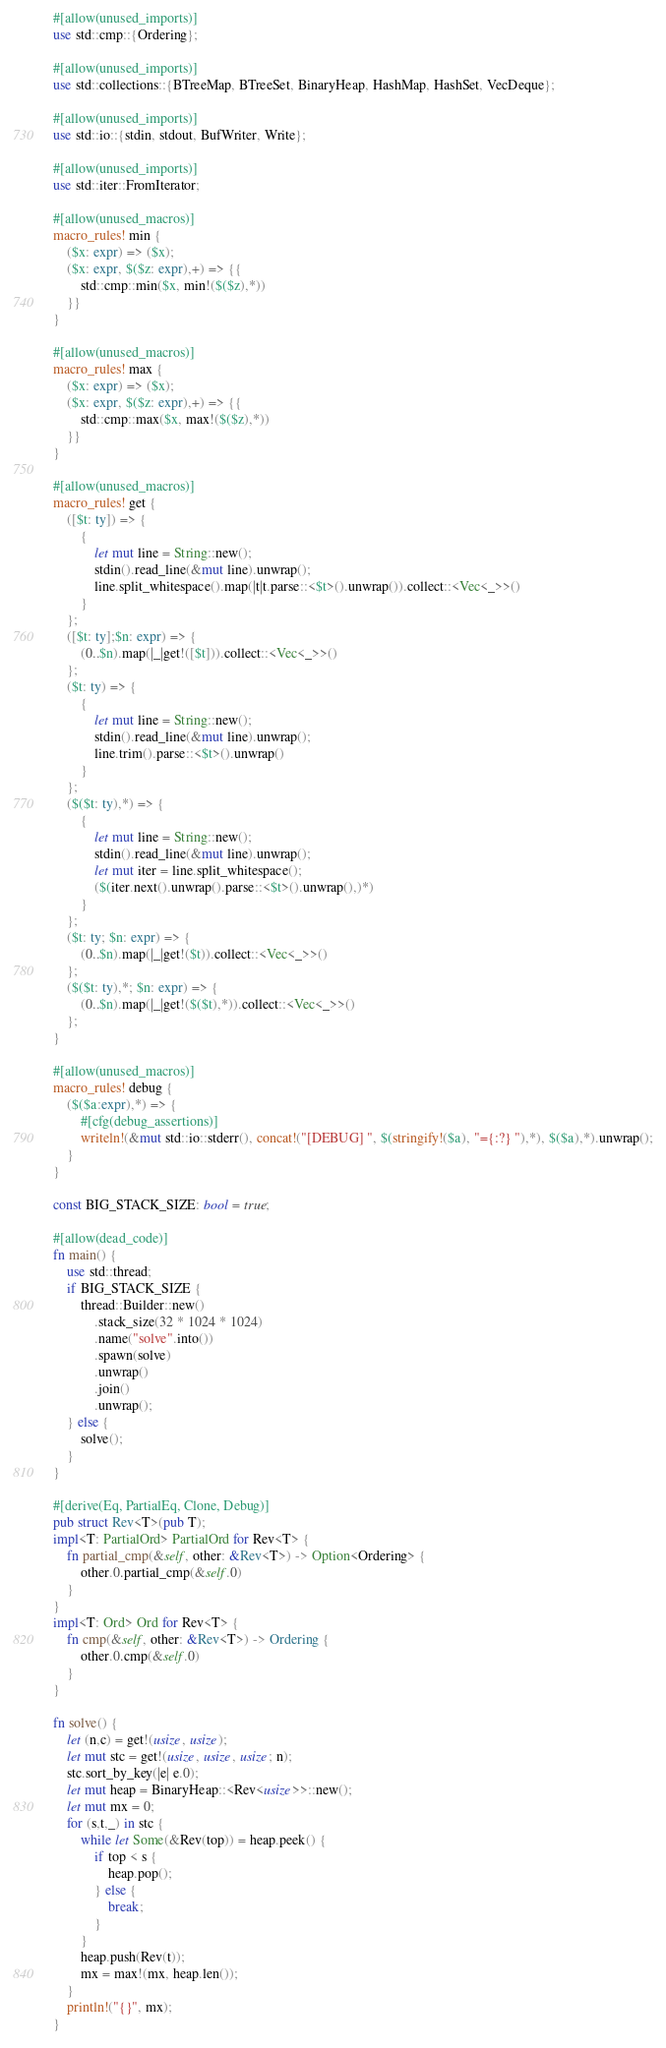<code> <loc_0><loc_0><loc_500><loc_500><_Rust_>#[allow(unused_imports)]
use std::cmp::{Ordering};

#[allow(unused_imports)]
use std::collections::{BTreeMap, BTreeSet, BinaryHeap, HashMap, HashSet, VecDeque};

#[allow(unused_imports)]
use std::io::{stdin, stdout, BufWriter, Write};

#[allow(unused_imports)]
use std::iter::FromIterator;

#[allow(unused_macros)]
macro_rules! min {
    ($x: expr) => ($x);
    ($x: expr, $($z: expr),+) => {{
        std::cmp::min($x, min!($($z),*))
    }}
}

#[allow(unused_macros)]
macro_rules! max {
    ($x: expr) => ($x);
    ($x: expr, $($z: expr),+) => {{
        std::cmp::max($x, max!($($z),*))
    }}
}

#[allow(unused_macros)]
macro_rules! get { 
    ([$t: ty]) => { 
        { 
            let mut line = String::new(); 
            stdin().read_line(&mut line).unwrap(); 
            line.split_whitespace().map(|t|t.parse::<$t>().unwrap()).collect::<Vec<_>>()
        }
    };
    ([$t: ty];$n: expr) => {
        (0..$n).map(|_|get!([$t])).collect::<Vec<_>>()
    };
    ($t: ty) => {
        {
            let mut line = String::new();
            stdin().read_line(&mut line).unwrap();
            line.trim().parse::<$t>().unwrap()
        }
    };
    ($($t: ty),*) => {
        { 
            let mut line = String::new();
            stdin().read_line(&mut line).unwrap();
            let mut iter = line.split_whitespace();
            ($(iter.next().unwrap().parse::<$t>().unwrap(),)*)
        }
    };
    ($t: ty; $n: expr) => {
        (0..$n).map(|_|get!($t)).collect::<Vec<_>>()
    };
    ($($t: ty),*; $n: expr) => {
        (0..$n).map(|_|get!($($t),*)).collect::<Vec<_>>()
    };
}

#[allow(unused_macros)]
macro_rules! debug {
    ($($a:expr),*) => {
        #[cfg(debug_assertions)]
        writeln!(&mut std::io::stderr(), concat!("[DEBUG] ", $(stringify!($a), "={:?} "),*), $($a),*).unwrap();
    }
}

const BIG_STACK_SIZE: bool = true;

#[allow(dead_code)]
fn main() {
    use std::thread;
    if BIG_STACK_SIZE {
        thread::Builder::new()
            .stack_size(32 * 1024 * 1024)
            .name("solve".into())
            .spawn(solve)
            .unwrap()
            .join()
            .unwrap();
    } else {
        solve();
    }
}

#[derive(Eq, PartialEq, Clone, Debug)]
pub struct Rev<T>(pub T);
impl<T: PartialOrd> PartialOrd for Rev<T> {
    fn partial_cmp(&self, other: &Rev<T>) -> Option<Ordering> {
        other.0.partial_cmp(&self.0)
    }
}
impl<T: Ord> Ord for Rev<T> {
    fn cmp(&self, other: &Rev<T>) -> Ordering {
        other.0.cmp(&self.0)
    }
}

fn solve() {
    let (n,c) = get!(usize, usize);
    let mut stc = get!(usize, usize, usize; n);
    stc.sort_by_key(|e| e.0);
    let mut heap = BinaryHeap::<Rev<usize>>::new();
    let mut mx = 0;
    for (s,t,_) in stc {
        while let Some(&Rev(top)) = heap.peek() {
            if top < s {
                heap.pop();
            } else {
                break;
            }
        }
        heap.push(Rev(t));
        mx = max!(mx, heap.len());
    }
    println!("{}", mx);
}
</code> 